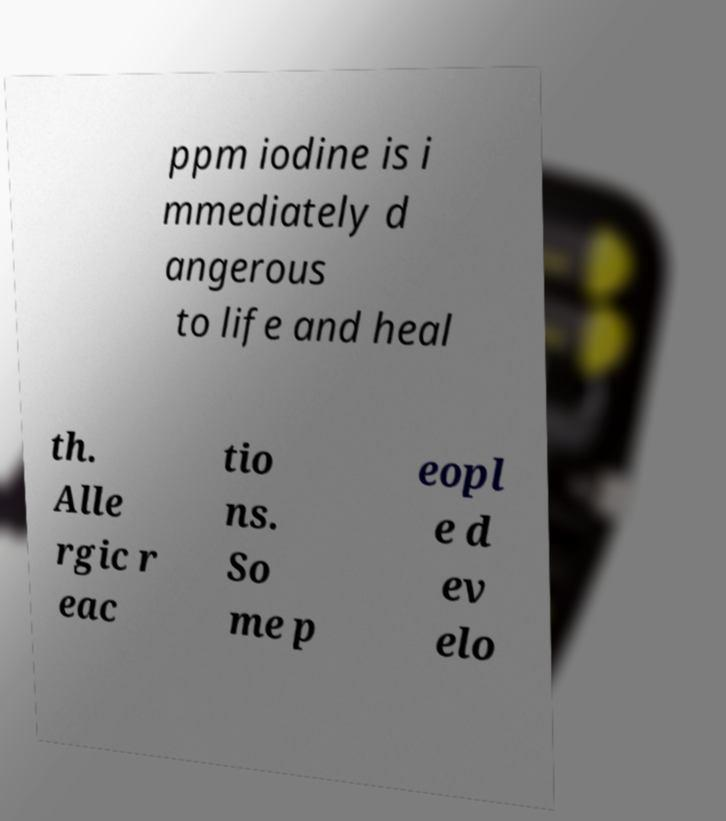There's text embedded in this image that I need extracted. Can you transcribe it verbatim? ppm iodine is i mmediately d angerous to life and heal th. Alle rgic r eac tio ns. So me p eopl e d ev elo 